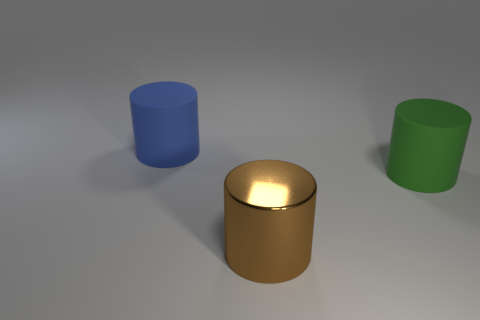Add 3 tiny red objects. How many objects exist? 6 Subtract all large brown metallic cylinders. Subtract all big green matte balls. How many objects are left? 2 Add 2 large matte cylinders. How many large matte cylinders are left? 4 Add 3 brown metal objects. How many brown metal objects exist? 4 Subtract 0 blue blocks. How many objects are left? 3 